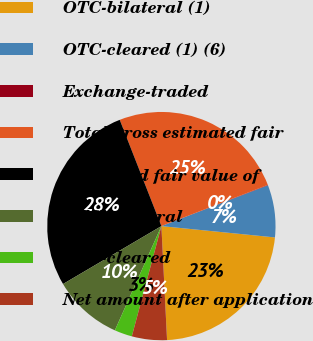<chart> <loc_0><loc_0><loc_500><loc_500><pie_chart><fcel>OTC-bilateral (1)<fcel>OTC-cleared (1) (6)<fcel>Exchange-traded<fcel>Total gross estimated fair<fcel>Estimated fair value of<fcel>OTC-bilateral<fcel>OTC-cleared<fcel>Net amount after application<nl><fcel>22.63%<fcel>7.4%<fcel>0.06%<fcel>25.07%<fcel>27.52%<fcel>9.85%<fcel>2.51%<fcel>4.96%<nl></chart> 